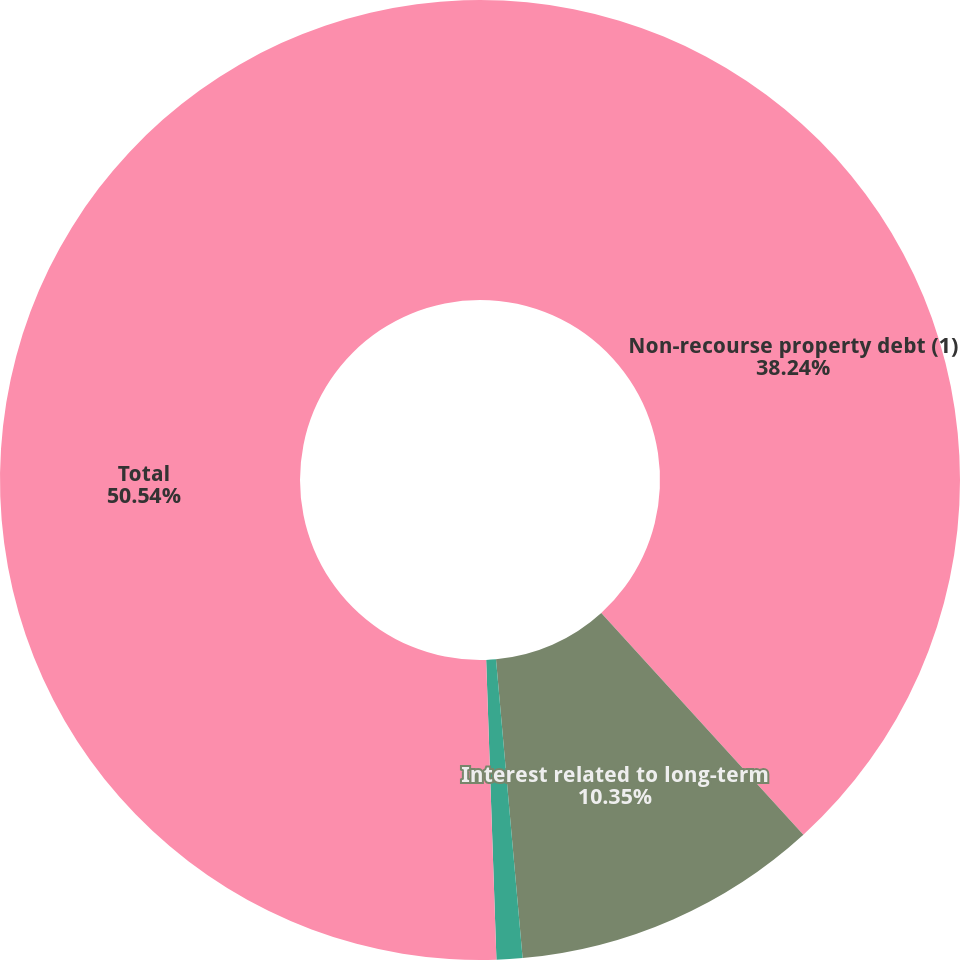<chart> <loc_0><loc_0><loc_500><loc_500><pie_chart><fcel>Non-recourse property debt (1)<fcel>Interest related to long-term<fcel>Ground lease obligations (4)<fcel>Total<nl><fcel>38.24%<fcel>10.35%<fcel>0.87%<fcel>50.55%<nl></chart> 